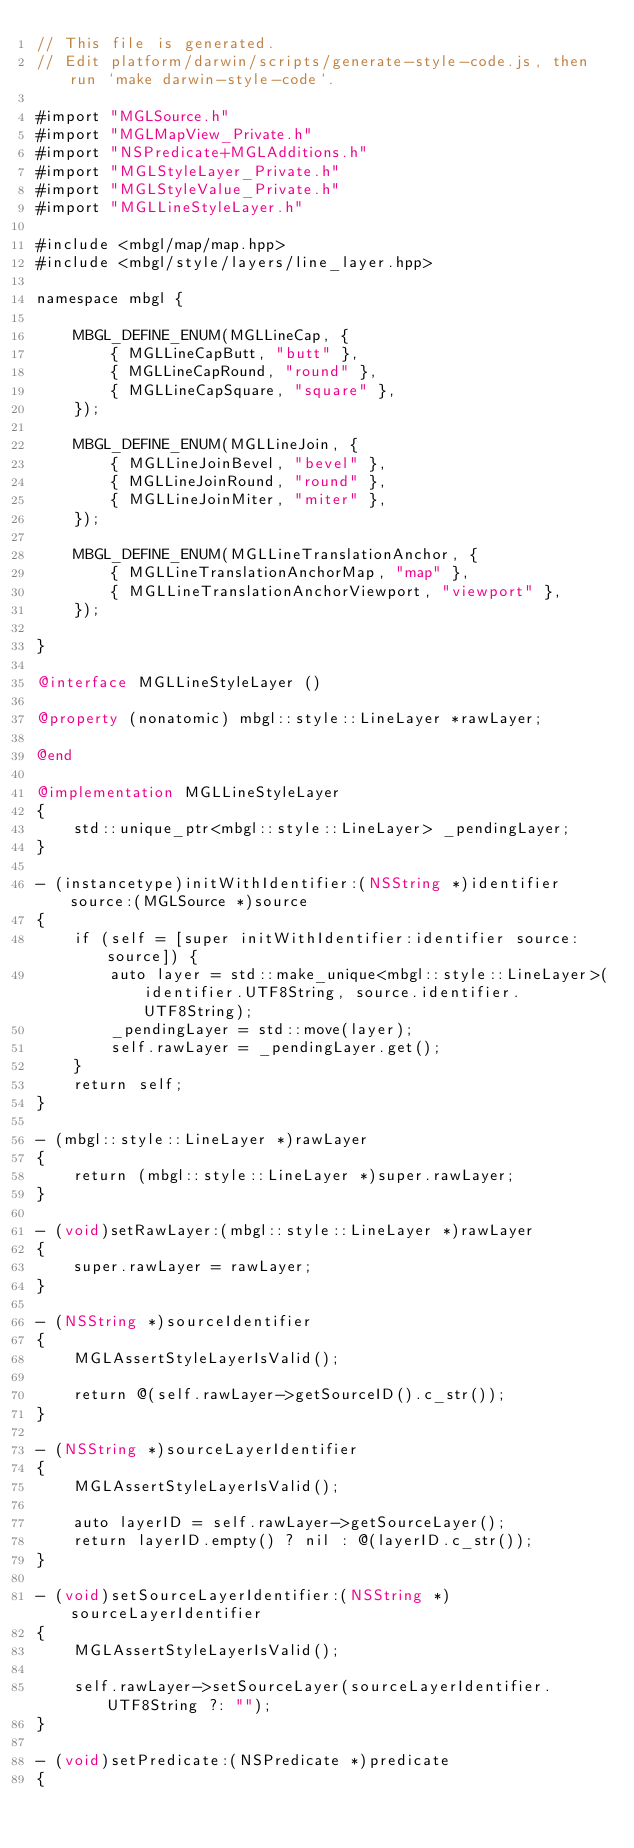Convert code to text. <code><loc_0><loc_0><loc_500><loc_500><_ObjectiveC_>// This file is generated.
// Edit platform/darwin/scripts/generate-style-code.js, then run `make darwin-style-code`.

#import "MGLSource.h"
#import "MGLMapView_Private.h"
#import "NSPredicate+MGLAdditions.h"
#import "MGLStyleLayer_Private.h"
#import "MGLStyleValue_Private.h"
#import "MGLLineStyleLayer.h"

#include <mbgl/map/map.hpp>
#include <mbgl/style/layers/line_layer.hpp>

namespace mbgl {

    MBGL_DEFINE_ENUM(MGLLineCap, {
        { MGLLineCapButt, "butt" },
        { MGLLineCapRound, "round" },
        { MGLLineCapSquare, "square" },
    });

    MBGL_DEFINE_ENUM(MGLLineJoin, {
        { MGLLineJoinBevel, "bevel" },
        { MGLLineJoinRound, "round" },
        { MGLLineJoinMiter, "miter" },
    });

    MBGL_DEFINE_ENUM(MGLLineTranslationAnchor, {
        { MGLLineTranslationAnchorMap, "map" },
        { MGLLineTranslationAnchorViewport, "viewport" },
    });

}

@interface MGLLineStyleLayer ()

@property (nonatomic) mbgl::style::LineLayer *rawLayer;

@end

@implementation MGLLineStyleLayer
{
    std::unique_ptr<mbgl::style::LineLayer> _pendingLayer;
}

- (instancetype)initWithIdentifier:(NSString *)identifier source:(MGLSource *)source
{
    if (self = [super initWithIdentifier:identifier source:source]) {
        auto layer = std::make_unique<mbgl::style::LineLayer>(identifier.UTF8String, source.identifier.UTF8String);
        _pendingLayer = std::move(layer);
        self.rawLayer = _pendingLayer.get();
    }
    return self;
}

- (mbgl::style::LineLayer *)rawLayer
{
    return (mbgl::style::LineLayer *)super.rawLayer;
}

- (void)setRawLayer:(mbgl::style::LineLayer *)rawLayer
{
    super.rawLayer = rawLayer;
}

- (NSString *)sourceIdentifier
{
    MGLAssertStyleLayerIsValid();

    return @(self.rawLayer->getSourceID().c_str());
}

- (NSString *)sourceLayerIdentifier
{
    MGLAssertStyleLayerIsValid();

    auto layerID = self.rawLayer->getSourceLayer();
    return layerID.empty() ? nil : @(layerID.c_str());
}

- (void)setSourceLayerIdentifier:(NSString *)sourceLayerIdentifier
{
    MGLAssertStyleLayerIsValid();

    self.rawLayer->setSourceLayer(sourceLayerIdentifier.UTF8String ?: "");
}

- (void)setPredicate:(NSPredicate *)predicate
{</code> 